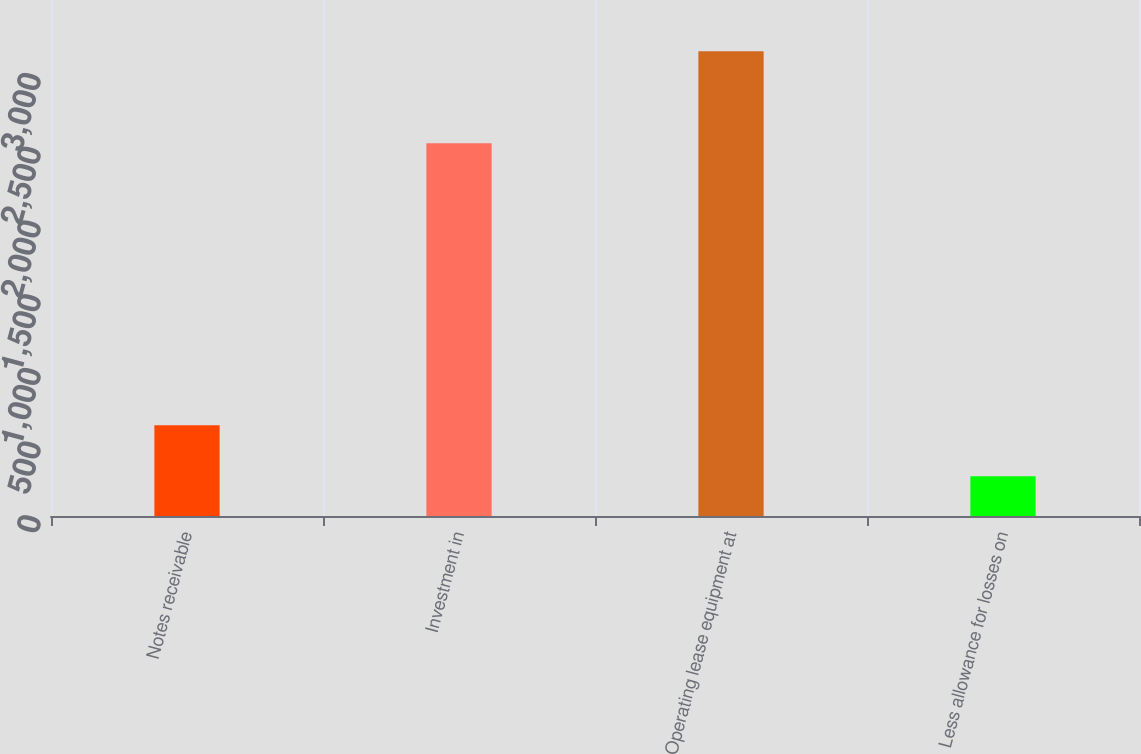Convert chart. <chart><loc_0><loc_0><loc_500><loc_500><bar_chart><fcel>Notes receivable<fcel>Investment in<fcel>Operating lease equipment at<fcel>Less allowance for losses on<nl><fcel>615<fcel>2528<fcel>3152<fcel>269<nl></chart> 